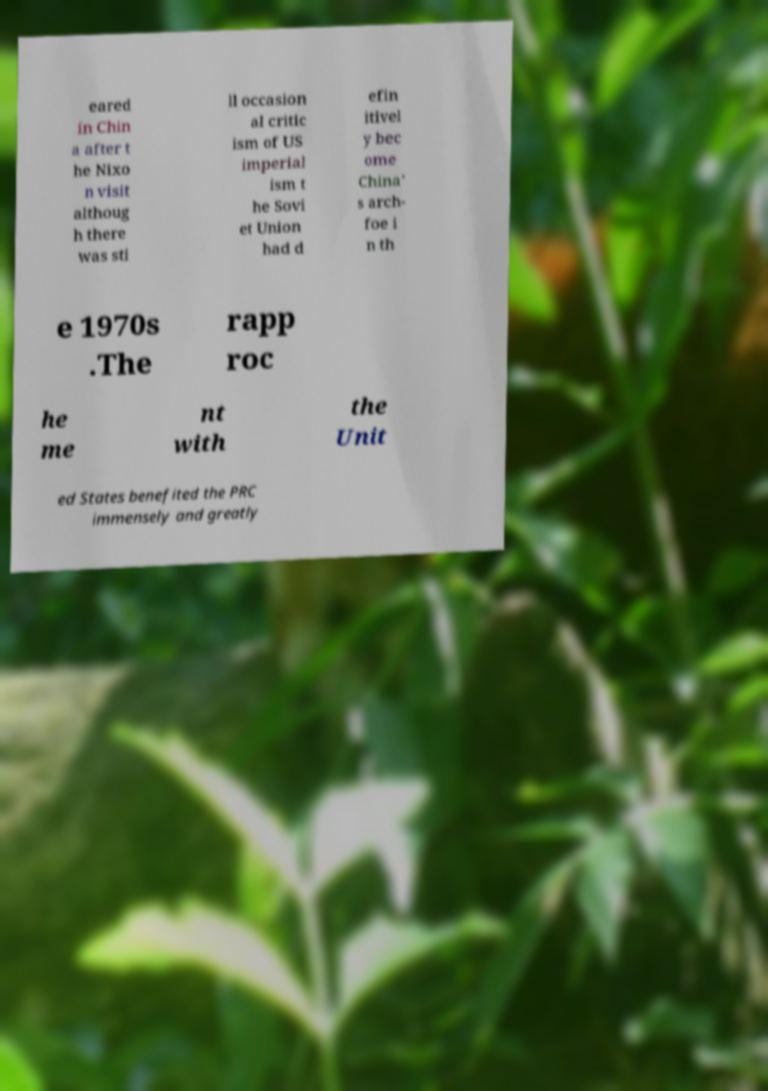Please identify and transcribe the text found in this image. eared in Chin a after t he Nixo n visit althoug h there was sti ll occasion al critic ism of US imperial ism t he Sovi et Union had d efin itivel y bec ome China' s arch- foe i n th e 1970s .The rapp roc he me nt with the Unit ed States benefited the PRC immensely and greatly 